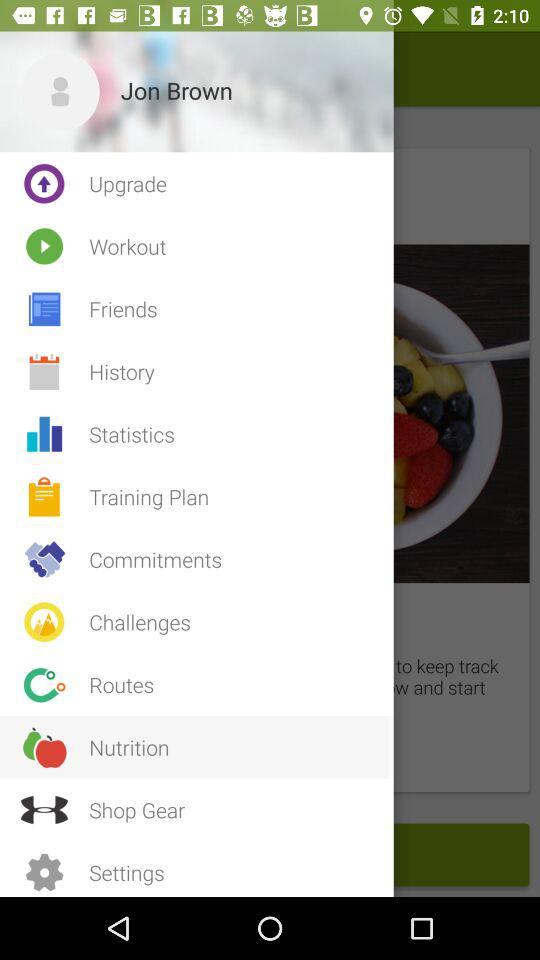What is the name of the user? The name of the user is Jon Brown. 